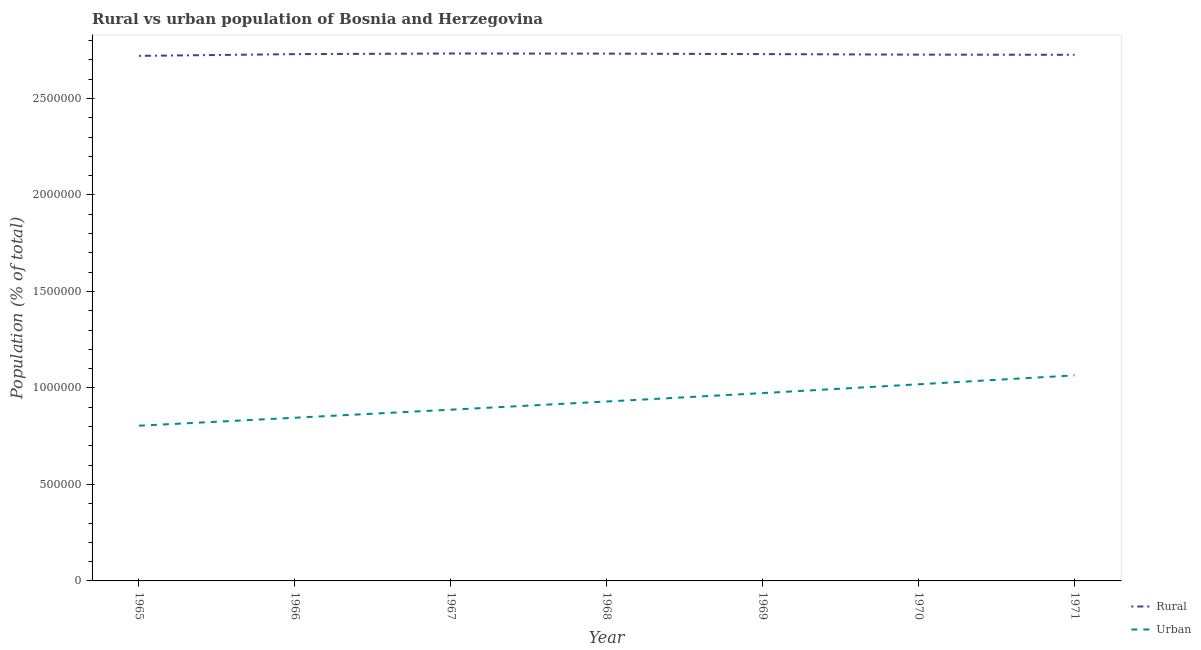How many different coloured lines are there?
Provide a short and direct response. 2. Does the line corresponding to urban population density intersect with the line corresponding to rural population density?
Your answer should be compact. No. Is the number of lines equal to the number of legend labels?
Your response must be concise. Yes. What is the rural population density in 1967?
Give a very brief answer. 2.73e+06. Across all years, what is the maximum rural population density?
Keep it short and to the point. 2.73e+06. Across all years, what is the minimum urban population density?
Give a very brief answer. 8.04e+05. In which year was the rural population density maximum?
Provide a short and direct response. 1967. In which year was the rural population density minimum?
Ensure brevity in your answer.  1965. What is the total urban population density in the graph?
Ensure brevity in your answer.  6.52e+06. What is the difference between the rural population density in 1967 and that in 1971?
Keep it short and to the point. 6853. What is the difference between the urban population density in 1965 and the rural population density in 1968?
Provide a succinct answer. -1.93e+06. What is the average urban population density per year?
Ensure brevity in your answer.  9.32e+05. In the year 1969, what is the difference between the rural population density and urban population density?
Provide a succinct answer. 1.76e+06. What is the ratio of the rural population density in 1965 to that in 1970?
Offer a very short reply. 1. Is the difference between the urban population density in 1965 and 1970 greater than the difference between the rural population density in 1965 and 1970?
Make the answer very short. No. What is the difference between the highest and the second highest urban population density?
Provide a short and direct response. 4.62e+04. What is the difference between the highest and the lowest urban population density?
Your answer should be compact. 2.61e+05. Does the rural population density monotonically increase over the years?
Ensure brevity in your answer.  No. Is the rural population density strictly greater than the urban population density over the years?
Provide a succinct answer. Yes. What is the difference between two consecutive major ticks on the Y-axis?
Provide a short and direct response. 5.00e+05. Does the graph contain grids?
Ensure brevity in your answer.  No. How many legend labels are there?
Offer a very short reply. 2. How are the legend labels stacked?
Provide a short and direct response. Vertical. What is the title of the graph?
Provide a succinct answer. Rural vs urban population of Bosnia and Herzegovina. Does "Excluding technical cooperation" appear as one of the legend labels in the graph?
Ensure brevity in your answer.  No. What is the label or title of the X-axis?
Your response must be concise. Year. What is the label or title of the Y-axis?
Your answer should be compact. Population (% of total). What is the Population (% of total) in Rural in 1965?
Give a very brief answer. 2.72e+06. What is the Population (% of total) in Urban in 1965?
Your answer should be compact. 8.04e+05. What is the Population (% of total) in Rural in 1966?
Offer a very short reply. 2.73e+06. What is the Population (% of total) in Urban in 1966?
Offer a very short reply. 8.46e+05. What is the Population (% of total) in Rural in 1967?
Make the answer very short. 2.73e+06. What is the Population (% of total) in Urban in 1967?
Keep it short and to the point. 8.87e+05. What is the Population (% of total) in Rural in 1968?
Your response must be concise. 2.73e+06. What is the Population (% of total) in Urban in 1968?
Give a very brief answer. 9.30e+05. What is the Population (% of total) of Rural in 1969?
Keep it short and to the point. 2.73e+06. What is the Population (% of total) of Urban in 1969?
Your answer should be compact. 9.73e+05. What is the Population (% of total) in Rural in 1970?
Keep it short and to the point. 2.73e+06. What is the Population (% of total) in Urban in 1970?
Offer a terse response. 1.02e+06. What is the Population (% of total) in Rural in 1971?
Provide a succinct answer. 2.73e+06. What is the Population (% of total) in Urban in 1971?
Make the answer very short. 1.07e+06. Across all years, what is the maximum Population (% of total) in Rural?
Offer a terse response. 2.73e+06. Across all years, what is the maximum Population (% of total) of Urban?
Your answer should be very brief. 1.07e+06. Across all years, what is the minimum Population (% of total) of Rural?
Offer a terse response. 2.72e+06. Across all years, what is the minimum Population (% of total) of Urban?
Keep it short and to the point. 8.04e+05. What is the total Population (% of total) of Rural in the graph?
Keep it short and to the point. 1.91e+07. What is the total Population (% of total) in Urban in the graph?
Give a very brief answer. 6.52e+06. What is the difference between the Population (% of total) of Rural in 1965 and that in 1966?
Keep it short and to the point. -9031. What is the difference between the Population (% of total) of Urban in 1965 and that in 1966?
Offer a very short reply. -4.13e+04. What is the difference between the Population (% of total) in Rural in 1965 and that in 1967?
Provide a succinct answer. -1.24e+04. What is the difference between the Population (% of total) of Urban in 1965 and that in 1967?
Ensure brevity in your answer.  -8.30e+04. What is the difference between the Population (% of total) of Rural in 1965 and that in 1968?
Offer a terse response. -1.17e+04. What is the difference between the Population (% of total) in Urban in 1965 and that in 1968?
Offer a terse response. -1.25e+05. What is the difference between the Population (% of total) in Rural in 1965 and that in 1969?
Your response must be concise. -9229. What is the difference between the Population (% of total) in Urban in 1965 and that in 1969?
Provide a short and direct response. -1.69e+05. What is the difference between the Population (% of total) in Rural in 1965 and that in 1970?
Offer a very short reply. -6397. What is the difference between the Population (% of total) in Urban in 1965 and that in 1970?
Your response must be concise. -2.15e+05. What is the difference between the Population (% of total) in Rural in 1965 and that in 1971?
Give a very brief answer. -5530. What is the difference between the Population (% of total) of Urban in 1965 and that in 1971?
Provide a succinct answer. -2.61e+05. What is the difference between the Population (% of total) of Rural in 1966 and that in 1967?
Offer a terse response. -3352. What is the difference between the Population (% of total) in Urban in 1966 and that in 1967?
Make the answer very short. -4.17e+04. What is the difference between the Population (% of total) in Rural in 1966 and that in 1968?
Offer a very short reply. -2641. What is the difference between the Population (% of total) in Urban in 1966 and that in 1968?
Ensure brevity in your answer.  -8.40e+04. What is the difference between the Population (% of total) in Rural in 1966 and that in 1969?
Make the answer very short. -198. What is the difference between the Population (% of total) in Urban in 1966 and that in 1969?
Provide a short and direct response. -1.28e+05. What is the difference between the Population (% of total) of Rural in 1966 and that in 1970?
Ensure brevity in your answer.  2634. What is the difference between the Population (% of total) in Urban in 1966 and that in 1970?
Provide a short and direct response. -1.73e+05. What is the difference between the Population (% of total) of Rural in 1966 and that in 1971?
Provide a short and direct response. 3501. What is the difference between the Population (% of total) in Urban in 1966 and that in 1971?
Ensure brevity in your answer.  -2.19e+05. What is the difference between the Population (% of total) of Rural in 1967 and that in 1968?
Offer a very short reply. 711. What is the difference between the Population (% of total) in Urban in 1967 and that in 1968?
Your response must be concise. -4.24e+04. What is the difference between the Population (% of total) of Rural in 1967 and that in 1969?
Offer a terse response. 3154. What is the difference between the Population (% of total) of Urban in 1967 and that in 1969?
Keep it short and to the point. -8.60e+04. What is the difference between the Population (% of total) of Rural in 1967 and that in 1970?
Offer a very short reply. 5986. What is the difference between the Population (% of total) of Urban in 1967 and that in 1970?
Provide a short and direct response. -1.32e+05. What is the difference between the Population (% of total) of Rural in 1967 and that in 1971?
Offer a very short reply. 6853. What is the difference between the Population (% of total) in Urban in 1967 and that in 1971?
Give a very brief answer. -1.78e+05. What is the difference between the Population (% of total) of Rural in 1968 and that in 1969?
Your answer should be very brief. 2443. What is the difference between the Population (% of total) in Urban in 1968 and that in 1969?
Keep it short and to the point. -4.36e+04. What is the difference between the Population (% of total) of Rural in 1968 and that in 1970?
Give a very brief answer. 5275. What is the difference between the Population (% of total) of Urban in 1968 and that in 1970?
Offer a very short reply. -8.93e+04. What is the difference between the Population (% of total) of Rural in 1968 and that in 1971?
Provide a succinct answer. 6142. What is the difference between the Population (% of total) of Urban in 1968 and that in 1971?
Provide a succinct answer. -1.35e+05. What is the difference between the Population (% of total) in Rural in 1969 and that in 1970?
Ensure brevity in your answer.  2832. What is the difference between the Population (% of total) in Urban in 1969 and that in 1970?
Your answer should be compact. -4.56e+04. What is the difference between the Population (% of total) of Rural in 1969 and that in 1971?
Give a very brief answer. 3699. What is the difference between the Population (% of total) in Urban in 1969 and that in 1971?
Your response must be concise. -9.18e+04. What is the difference between the Population (% of total) in Rural in 1970 and that in 1971?
Make the answer very short. 867. What is the difference between the Population (% of total) of Urban in 1970 and that in 1971?
Provide a succinct answer. -4.62e+04. What is the difference between the Population (% of total) of Rural in 1965 and the Population (% of total) of Urban in 1966?
Keep it short and to the point. 1.87e+06. What is the difference between the Population (% of total) in Rural in 1965 and the Population (% of total) in Urban in 1967?
Your answer should be very brief. 1.83e+06. What is the difference between the Population (% of total) in Rural in 1965 and the Population (% of total) in Urban in 1968?
Make the answer very short. 1.79e+06. What is the difference between the Population (% of total) in Rural in 1965 and the Population (% of total) in Urban in 1969?
Your answer should be compact. 1.75e+06. What is the difference between the Population (% of total) in Rural in 1965 and the Population (% of total) in Urban in 1970?
Offer a very short reply. 1.70e+06. What is the difference between the Population (% of total) of Rural in 1965 and the Population (% of total) of Urban in 1971?
Keep it short and to the point. 1.66e+06. What is the difference between the Population (% of total) in Rural in 1966 and the Population (% of total) in Urban in 1967?
Your answer should be compact. 1.84e+06. What is the difference between the Population (% of total) in Rural in 1966 and the Population (% of total) in Urban in 1968?
Your response must be concise. 1.80e+06. What is the difference between the Population (% of total) in Rural in 1966 and the Population (% of total) in Urban in 1969?
Your answer should be very brief. 1.76e+06. What is the difference between the Population (% of total) in Rural in 1966 and the Population (% of total) in Urban in 1970?
Your answer should be very brief. 1.71e+06. What is the difference between the Population (% of total) of Rural in 1966 and the Population (% of total) of Urban in 1971?
Keep it short and to the point. 1.66e+06. What is the difference between the Population (% of total) in Rural in 1967 and the Population (% of total) in Urban in 1968?
Give a very brief answer. 1.80e+06. What is the difference between the Population (% of total) of Rural in 1967 and the Population (% of total) of Urban in 1969?
Keep it short and to the point. 1.76e+06. What is the difference between the Population (% of total) of Rural in 1967 and the Population (% of total) of Urban in 1970?
Give a very brief answer. 1.71e+06. What is the difference between the Population (% of total) in Rural in 1967 and the Population (% of total) in Urban in 1971?
Your answer should be compact. 1.67e+06. What is the difference between the Population (% of total) of Rural in 1968 and the Population (% of total) of Urban in 1969?
Offer a very short reply. 1.76e+06. What is the difference between the Population (% of total) of Rural in 1968 and the Population (% of total) of Urban in 1970?
Provide a succinct answer. 1.71e+06. What is the difference between the Population (% of total) of Rural in 1968 and the Population (% of total) of Urban in 1971?
Offer a terse response. 1.67e+06. What is the difference between the Population (% of total) in Rural in 1969 and the Population (% of total) in Urban in 1970?
Keep it short and to the point. 1.71e+06. What is the difference between the Population (% of total) in Rural in 1969 and the Population (% of total) in Urban in 1971?
Keep it short and to the point. 1.66e+06. What is the difference between the Population (% of total) of Rural in 1970 and the Population (% of total) of Urban in 1971?
Your response must be concise. 1.66e+06. What is the average Population (% of total) in Rural per year?
Ensure brevity in your answer.  2.73e+06. What is the average Population (% of total) in Urban per year?
Ensure brevity in your answer.  9.32e+05. In the year 1965, what is the difference between the Population (% of total) in Rural and Population (% of total) in Urban?
Give a very brief answer. 1.92e+06. In the year 1966, what is the difference between the Population (% of total) in Rural and Population (% of total) in Urban?
Offer a terse response. 1.88e+06. In the year 1967, what is the difference between the Population (% of total) in Rural and Population (% of total) in Urban?
Your answer should be very brief. 1.85e+06. In the year 1968, what is the difference between the Population (% of total) of Rural and Population (% of total) of Urban?
Ensure brevity in your answer.  1.80e+06. In the year 1969, what is the difference between the Population (% of total) of Rural and Population (% of total) of Urban?
Offer a very short reply. 1.76e+06. In the year 1970, what is the difference between the Population (% of total) of Rural and Population (% of total) of Urban?
Offer a terse response. 1.71e+06. In the year 1971, what is the difference between the Population (% of total) of Rural and Population (% of total) of Urban?
Your answer should be very brief. 1.66e+06. What is the ratio of the Population (% of total) in Urban in 1965 to that in 1966?
Your answer should be compact. 0.95. What is the ratio of the Population (% of total) of Rural in 1965 to that in 1967?
Your answer should be very brief. 1. What is the ratio of the Population (% of total) of Urban in 1965 to that in 1967?
Give a very brief answer. 0.91. What is the ratio of the Population (% of total) of Urban in 1965 to that in 1968?
Keep it short and to the point. 0.87. What is the ratio of the Population (% of total) of Urban in 1965 to that in 1969?
Make the answer very short. 0.83. What is the ratio of the Population (% of total) of Urban in 1965 to that in 1970?
Your answer should be very brief. 0.79. What is the ratio of the Population (% of total) of Urban in 1965 to that in 1971?
Offer a very short reply. 0.76. What is the ratio of the Population (% of total) of Urban in 1966 to that in 1967?
Offer a very short reply. 0.95. What is the ratio of the Population (% of total) of Urban in 1966 to that in 1968?
Give a very brief answer. 0.91. What is the ratio of the Population (% of total) of Rural in 1966 to that in 1969?
Your answer should be compact. 1. What is the ratio of the Population (% of total) of Urban in 1966 to that in 1969?
Provide a short and direct response. 0.87. What is the ratio of the Population (% of total) of Rural in 1966 to that in 1970?
Offer a terse response. 1. What is the ratio of the Population (% of total) of Urban in 1966 to that in 1970?
Provide a succinct answer. 0.83. What is the ratio of the Population (% of total) of Urban in 1966 to that in 1971?
Provide a succinct answer. 0.79. What is the ratio of the Population (% of total) in Urban in 1967 to that in 1968?
Your answer should be compact. 0.95. What is the ratio of the Population (% of total) in Urban in 1967 to that in 1969?
Your answer should be compact. 0.91. What is the ratio of the Population (% of total) of Urban in 1967 to that in 1970?
Your answer should be compact. 0.87. What is the ratio of the Population (% of total) of Rural in 1967 to that in 1971?
Provide a succinct answer. 1. What is the ratio of the Population (% of total) of Urban in 1967 to that in 1971?
Your answer should be very brief. 0.83. What is the ratio of the Population (% of total) of Urban in 1968 to that in 1969?
Your answer should be very brief. 0.96. What is the ratio of the Population (% of total) in Urban in 1968 to that in 1970?
Ensure brevity in your answer.  0.91. What is the ratio of the Population (% of total) in Urban in 1968 to that in 1971?
Offer a very short reply. 0.87. What is the ratio of the Population (% of total) of Urban in 1969 to that in 1970?
Your response must be concise. 0.96. What is the ratio of the Population (% of total) in Urban in 1969 to that in 1971?
Give a very brief answer. 0.91. What is the ratio of the Population (% of total) of Rural in 1970 to that in 1971?
Your answer should be very brief. 1. What is the ratio of the Population (% of total) in Urban in 1970 to that in 1971?
Provide a succinct answer. 0.96. What is the difference between the highest and the second highest Population (% of total) in Rural?
Give a very brief answer. 711. What is the difference between the highest and the second highest Population (% of total) in Urban?
Keep it short and to the point. 4.62e+04. What is the difference between the highest and the lowest Population (% of total) in Rural?
Provide a succinct answer. 1.24e+04. What is the difference between the highest and the lowest Population (% of total) of Urban?
Keep it short and to the point. 2.61e+05. 